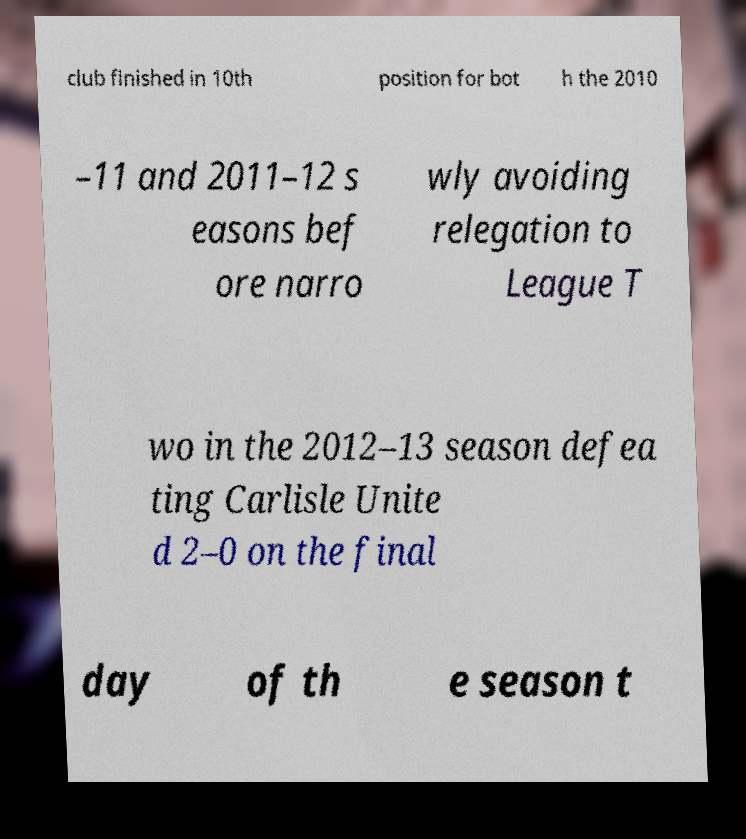For documentation purposes, I need the text within this image transcribed. Could you provide that? club finished in 10th position for bot h the 2010 –11 and 2011–12 s easons bef ore narro wly avoiding relegation to League T wo in the 2012–13 season defea ting Carlisle Unite d 2–0 on the final day of th e season t 